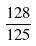Convert formula to latex. <formula><loc_0><loc_0><loc_500><loc_500>\frac { 1 2 8 } { 1 2 5 }</formula> 